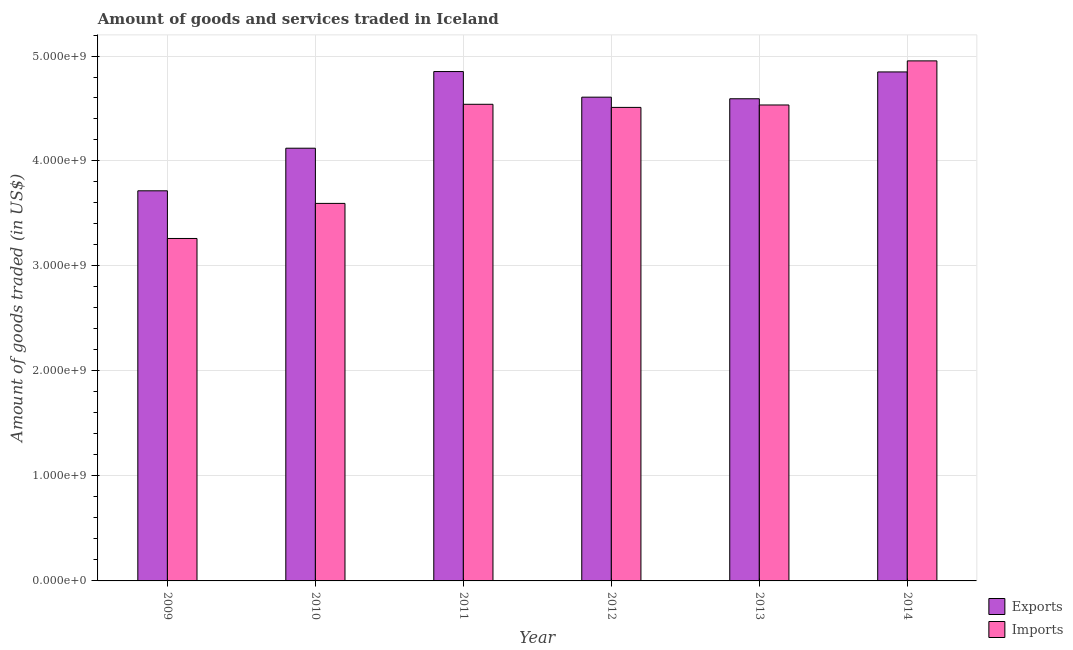How many bars are there on the 2nd tick from the left?
Your response must be concise. 2. What is the amount of goods exported in 2014?
Your answer should be compact. 4.85e+09. Across all years, what is the maximum amount of goods imported?
Keep it short and to the point. 4.95e+09. Across all years, what is the minimum amount of goods exported?
Your response must be concise. 3.72e+09. What is the total amount of goods imported in the graph?
Ensure brevity in your answer.  2.54e+1. What is the difference between the amount of goods imported in 2009 and that in 2010?
Offer a terse response. -3.34e+08. What is the difference between the amount of goods exported in 2014 and the amount of goods imported in 2010?
Provide a succinct answer. 7.27e+08. What is the average amount of goods imported per year?
Your response must be concise. 4.23e+09. In how many years, is the amount of goods exported greater than 400000000 US$?
Give a very brief answer. 6. What is the ratio of the amount of goods exported in 2011 to that in 2014?
Your response must be concise. 1. Is the amount of goods imported in 2011 less than that in 2013?
Keep it short and to the point. No. What is the difference between the highest and the second highest amount of goods exported?
Give a very brief answer. 3.53e+06. What is the difference between the highest and the lowest amount of goods exported?
Give a very brief answer. 1.14e+09. In how many years, is the amount of goods exported greater than the average amount of goods exported taken over all years?
Make the answer very short. 4. What does the 1st bar from the left in 2009 represents?
Your answer should be very brief. Exports. What does the 2nd bar from the right in 2009 represents?
Ensure brevity in your answer.  Exports. How many years are there in the graph?
Your answer should be compact. 6. What is the difference between two consecutive major ticks on the Y-axis?
Offer a very short reply. 1.00e+09. Are the values on the major ticks of Y-axis written in scientific E-notation?
Ensure brevity in your answer.  Yes. Does the graph contain grids?
Keep it short and to the point. Yes. Where does the legend appear in the graph?
Ensure brevity in your answer.  Bottom right. What is the title of the graph?
Make the answer very short. Amount of goods and services traded in Iceland. Does "% of gross capital formation" appear as one of the legend labels in the graph?
Your answer should be compact. No. What is the label or title of the X-axis?
Keep it short and to the point. Year. What is the label or title of the Y-axis?
Ensure brevity in your answer.  Amount of goods traded (in US$). What is the Amount of goods traded (in US$) of Exports in 2009?
Your answer should be very brief. 3.72e+09. What is the Amount of goods traded (in US$) of Imports in 2009?
Keep it short and to the point. 3.26e+09. What is the Amount of goods traded (in US$) in Exports in 2010?
Your answer should be compact. 4.12e+09. What is the Amount of goods traded (in US$) in Imports in 2010?
Give a very brief answer. 3.60e+09. What is the Amount of goods traded (in US$) in Exports in 2011?
Offer a very short reply. 4.85e+09. What is the Amount of goods traded (in US$) of Imports in 2011?
Your answer should be very brief. 4.54e+09. What is the Amount of goods traded (in US$) in Exports in 2012?
Provide a short and direct response. 4.61e+09. What is the Amount of goods traded (in US$) in Imports in 2012?
Your response must be concise. 4.51e+09. What is the Amount of goods traded (in US$) of Exports in 2013?
Provide a short and direct response. 4.59e+09. What is the Amount of goods traded (in US$) in Imports in 2013?
Offer a terse response. 4.53e+09. What is the Amount of goods traded (in US$) in Exports in 2014?
Provide a short and direct response. 4.85e+09. What is the Amount of goods traded (in US$) of Imports in 2014?
Provide a succinct answer. 4.95e+09. Across all years, what is the maximum Amount of goods traded (in US$) in Exports?
Offer a terse response. 4.85e+09. Across all years, what is the maximum Amount of goods traded (in US$) in Imports?
Keep it short and to the point. 4.95e+09. Across all years, what is the minimum Amount of goods traded (in US$) in Exports?
Ensure brevity in your answer.  3.72e+09. Across all years, what is the minimum Amount of goods traded (in US$) in Imports?
Your answer should be compact. 3.26e+09. What is the total Amount of goods traded (in US$) of Exports in the graph?
Provide a short and direct response. 2.67e+1. What is the total Amount of goods traded (in US$) of Imports in the graph?
Offer a very short reply. 2.54e+1. What is the difference between the Amount of goods traded (in US$) of Exports in 2009 and that in 2010?
Your answer should be compact. -4.06e+08. What is the difference between the Amount of goods traded (in US$) of Imports in 2009 and that in 2010?
Give a very brief answer. -3.34e+08. What is the difference between the Amount of goods traded (in US$) in Exports in 2009 and that in 2011?
Give a very brief answer. -1.14e+09. What is the difference between the Amount of goods traded (in US$) of Imports in 2009 and that in 2011?
Ensure brevity in your answer.  -1.28e+09. What is the difference between the Amount of goods traded (in US$) in Exports in 2009 and that in 2012?
Offer a very short reply. -8.92e+08. What is the difference between the Amount of goods traded (in US$) of Imports in 2009 and that in 2012?
Give a very brief answer. -1.25e+09. What is the difference between the Amount of goods traded (in US$) of Exports in 2009 and that in 2013?
Your response must be concise. -8.77e+08. What is the difference between the Amount of goods traded (in US$) in Imports in 2009 and that in 2013?
Give a very brief answer. -1.27e+09. What is the difference between the Amount of goods traded (in US$) in Exports in 2009 and that in 2014?
Your answer should be very brief. -1.13e+09. What is the difference between the Amount of goods traded (in US$) in Imports in 2009 and that in 2014?
Provide a short and direct response. -1.69e+09. What is the difference between the Amount of goods traded (in US$) of Exports in 2010 and that in 2011?
Give a very brief answer. -7.30e+08. What is the difference between the Amount of goods traded (in US$) in Imports in 2010 and that in 2011?
Your answer should be compact. -9.44e+08. What is the difference between the Amount of goods traded (in US$) in Exports in 2010 and that in 2012?
Make the answer very short. -4.86e+08. What is the difference between the Amount of goods traded (in US$) in Imports in 2010 and that in 2012?
Your answer should be compact. -9.14e+08. What is the difference between the Amount of goods traded (in US$) in Exports in 2010 and that in 2013?
Offer a terse response. -4.71e+08. What is the difference between the Amount of goods traded (in US$) in Imports in 2010 and that in 2013?
Give a very brief answer. -9.37e+08. What is the difference between the Amount of goods traded (in US$) in Exports in 2010 and that in 2014?
Your answer should be very brief. -7.27e+08. What is the difference between the Amount of goods traded (in US$) of Imports in 2010 and that in 2014?
Your response must be concise. -1.36e+09. What is the difference between the Amount of goods traded (in US$) in Exports in 2011 and that in 2012?
Ensure brevity in your answer.  2.44e+08. What is the difference between the Amount of goods traded (in US$) in Imports in 2011 and that in 2012?
Offer a terse response. 2.95e+07. What is the difference between the Amount of goods traded (in US$) in Exports in 2011 and that in 2013?
Provide a short and direct response. 2.59e+08. What is the difference between the Amount of goods traded (in US$) of Imports in 2011 and that in 2013?
Offer a terse response. 6.52e+06. What is the difference between the Amount of goods traded (in US$) of Exports in 2011 and that in 2014?
Your answer should be very brief. 3.53e+06. What is the difference between the Amount of goods traded (in US$) of Imports in 2011 and that in 2014?
Your response must be concise. -4.14e+08. What is the difference between the Amount of goods traded (in US$) of Exports in 2012 and that in 2013?
Ensure brevity in your answer.  1.52e+07. What is the difference between the Amount of goods traded (in US$) of Imports in 2012 and that in 2013?
Your answer should be very brief. -2.30e+07. What is the difference between the Amount of goods traded (in US$) of Exports in 2012 and that in 2014?
Make the answer very short. -2.40e+08. What is the difference between the Amount of goods traded (in US$) in Imports in 2012 and that in 2014?
Keep it short and to the point. -4.43e+08. What is the difference between the Amount of goods traded (in US$) of Exports in 2013 and that in 2014?
Your response must be concise. -2.56e+08. What is the difference between the Amount of goods traded (in US$) in Imports in 2013 and that in 2014?
Offer a terse response. -4.20e+08. What is the difference between the Amount of goods traded (in US$) of Exports in 2009 and the Amount of goods traded (in US$) of Imports in 2010?
Provide a short and direct response. 1.20e+08. What is the difference between the Amount of goods traded (in US$) in Exports in 2009 and the Amount of goods traded (in US$) in Imports in 2011?
Your response must be concise. -8.24e+08. What is the difference between the Amount of goods traded (in US$) of Exports in 2009 and the Amount of goods traded (in US$) of Imports in 2012?
Provide a succinct answer. -7.94e+08. What is the difference between the Amount of goods traded (in US$) in Exports in 2009 and the Amount of goods traded (in US$) in Imports in 2013?
Provide a short and direct response. -8.17e+08. What is the difference between the Amount of goods traded (in US$) of Exports in 2009 and the Amount of goods traded (in US$) of Imports in 2014?
Keep it short and to the point. -1.24e+09. What is the difference between the Amount of goods traded (in US$) of Exports in 2010 and the Amount of goods traded (in US$) of Imports in 2011?
Make the answer very short. -4.18e+08. What is the difference between the Amount of goods traded (in US$) in Exports in 2010 and the Amount of goods traded (in US$) in Imports in 2012?
Your response must be concise. -3.89e+08. What is the difference between the Amount of goods traded (in US$) in Exports in 2010 and the Amount of goods traded (in US$) in Imports in 2013?
Your answer should be compact. -4.12e+08. What is the difference between the Amount of goods traded (in US$) of Exports in 2010 and the Amount of goods traded (in US$) of Imports in 2014?
Offer a terse response. -8.32e+08. What is the difference between the Amount of goods traded (in US$) in Exports in 2011 and the Amount of goods traded (in US$) in Imports in 2012?
Provide a succinct answer. 3.41e+08. What is the difference between the Amount of goods traded (in US$) of Exports in 2011 and the Amount of goods traded (in US$) of Imports in 2013?
Offer a terse response. 3.18e+08. What is the difference between the Amount of goods traded (in US$) of Exports in 2011 and the Amount of goods traded (in US$) of Imports in 2014?
Your response must be concise. -1.02e+08. What is the difference between the Amount of goods traded (in US$) of Exports in 2012 and the Amount of goods traded (in US$) of Imports in 2013?
Ensure brevity in your answer.  7.44e+07. What is the difference between the Amount of goods traded (in US$) of Exports in 2012 and the Amount of goods traded (in US$) of Imports in 2014?
Provide a succinct answer. -3.46e+08. What is the difference between the Amount of goods traded (in US$) of Exports in 2013 and the Amount of goods traded (in US$) of Imports in 2014?
Offer a very short reply. -3.61e+08. What is the average Amount of goods traded (in US$) of Exports per year?
Keep it short and to the point. 4.46e+09. What is the average Amount of goods traded (in US$) in Imports per year?
Ensure brevity in your answer.  4.23e+09. In the year 2009, what is the difference between the Amount of goods traded (in US$) in Exports and Amount of goods traded (in US$) in Imports?
Provide a succinct answer. 4.54e+08. In the year 2010, what is the difference between the Amount of goods traded (in US$) in Exports and Amount of goods traded (in US$) in Imports?
Keep it short and to the point. 5.26e+08. In the year 2011, what is the difference between the Amount of goods traded (in US$) in Exports and Amount of goods traded (in US$) in Imports?
Offer a very short reply. 3.12e+08. In the year 2012, what is the difference between the Amount of goods traded (in US$) in Exports and Amount of goods traded (in US$) in Imports?
Make the answer very short. 9.74e+07. In the year 2013, what is the difference between the Amount of goods traded (in US$) of Exports and Amount of goods traded (in US$) of Imports?
Offer a terse response. 5.92e+07. In the year 2014, what is the difference between the Amount of goods traded (in US$) of Exports and Amount of goods traded (in US$) of Imports?
Give a very brief answer. -1.05e+08. What is the ratio of the Amount of goods traded (in US$) in Exports in 2009 to that in 2010?
Ensure brevity in your answer.  0.9. What is the ratio of the Amount of goods traded (in US$) of Imports in 2009 to that in 2010?
Offer a very short reply. 0.91. What is the ratio of the Amount of goods traded (in US$) of Exports in 2009 to that in 2011?
Your answer should be compact. 0.77. What is the ratio of the Amount of goods traded (in US$) of Imports in 2009 to that in 2011?
Keep it short and to the point. 0.72. What is the ratio of the Amount of goods traded (in US$) in Exports in 2009 to that in 2012?
Ensure brevity in your answer.  0.81. What is the ratio of the Amount of goods traded (in US$) in Imports in 2009 to that in 2012?
Ensure brevity in your answer.  0.72. What is the ratio of the Amount of goods traded (in US$) in Exports in 2009 to that in 2013?
Provide a short and direct response. 0.81. What is the ratio of the Amount of goods traded (in US$) of Imports in 2009 to that in 2013?
Keep it short and to the point. 0.72. What is the ratio of the Amount of goods traded (in US$) of Exports in 2009 to that in 2014?
Offer a terse response. 0.77. What is the ratio of the Amount of goods traded (in US$) of Imports in 2009 to that in 2014?
Provide a succinct answer. 0.66. What is the ratio of the Amount of goods traded (in US$) in Exports in 2010 to that in 2011?
Offer a very short reply. 0.85. What is the ratio of the Amount of goods traded (in US$) in Imports in 2010 to that in 2011?
Ensure brevity in your answer.  0.79. What is the ratio of the Amount of goods traded (in US$) in Exports in 2010 to that in 2012?
Make the answer very short. 0.89. What is the ratio of the Amount of goods traded (in US$) in Imports in 2010 to that in 2012?
Offer a terse response. 0.8. What is the ratio of the Amount of goods traded (in US$) of Exports in 2010 to that in 2013?
Offer a terse response. 0.9. What is the ratio of the Amount of goods traded (in US$) of Imports in 2010 to that in 2013?
Give a very brief answer. 0.79. What is the ratio of the Amount of goods traded (in US$) of Exports in 2010 to that in 2014?
Your answer should be very brief. 0.85. What is the ratio of the Amount of goods traded (in US$) of Imports in 2010 to that in 2014?
Keep it short and to the point. 0.73. What is the ratio of the Amount of goods traded (in US$) in Exports in 2011 to that in 2012?
Keep it short and to the point. 1.05. What is the ratio of the Amount of goods traded (in US$) in Exports in 2011 to that in 2013?
Your answer should be very brief. 1.06. What is the ratio of the Amount of goods traded (in US$) in Imports in 2011 to that in 2013?
Provide a succinct answer. 1. What is the ratio of the Amount of goods traded (in US$) in Exports in 2011 to that in 2014?
Provide a short and direct response. 1. What is the ratio of the Amount of goods traded (in US$) of Imports in 2011 to that in 2014?
Give a very brief answer. 0.92. What is the ratio of the Amount of goods traded (in US$) of Exports in 2012 to that in 2013?
Keep it short and to the point. 1. What is the ratio of the Amount of goods traded (in US$) of Exports in 2012 to that in 2014?
Make the answer very short. 0.95. What is the ratio of the Amount of goods traded (in US$) in Imports in 2012 to that in 2014?
Your response must be concise. 0.91. What is the ratio of the Amount of goods traded (in US$) in Exports in 2013 to that in 2014?
Your answer should be very brief. 0.95. What is the ratio of the Amount of goods traded (in US$) in Imports in 2013 to that in 2014?
Your response must be concise. 0.92. What is the difference between the highest and the second highest Amount of goods traded (in US$) in Exports?
Give a very brief answer. 3.53e+06. What is the difference between the highest and the second highest Amount of goods traded (in US$) in Imports?
Your answer should be compact. 4.14e+08. What is the difference between the highest and the lowest Amount of goods traded (in US$) in Exports?
Your answer should be very brief. 1.14e+09. What is the difference between the highest and the lowest Amount of goods traded (in US$) of Imports?
Make the answer very short. 1.69e+09. 